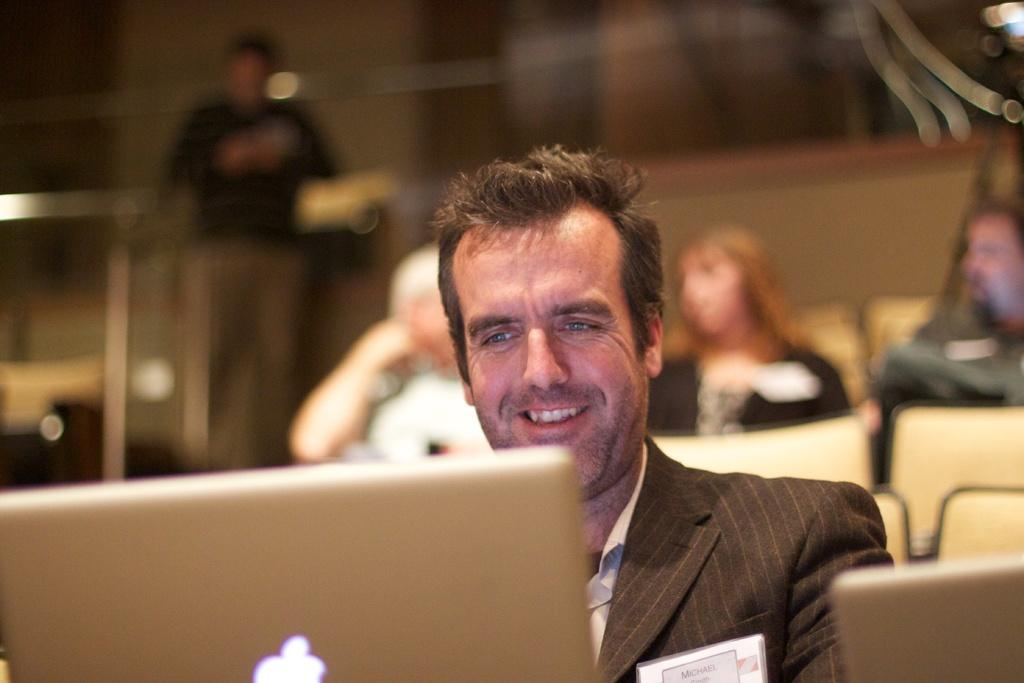What is the person in the image doing while sitting on the chair? The person is using a laptop. Can you describe the setting in the background of the image? There are persons, chairs, and a wall in the background of the image. What type of magic is the person performing with their breakfast in the image? There is no mention of breakfast or magic in the image; the person is using a laptop. 